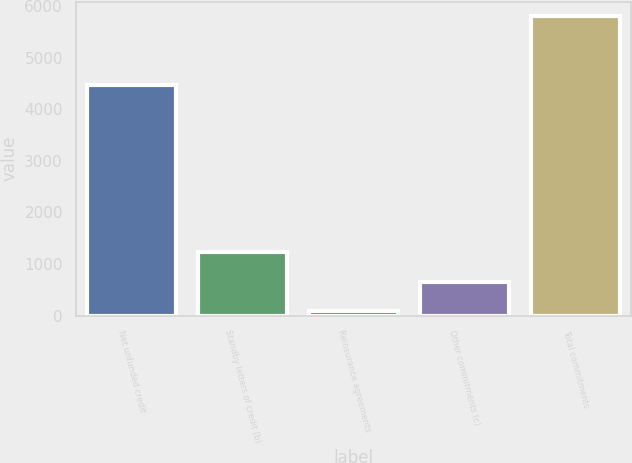Convert chart to OTSL. <chart><loc_0><loc_0><loc_500><loc_500><bar_chart><fcel>Net unfunded credit<fcel>Standby letters of credit (b)<fcel>Reinsurance agreements<fcel>Other commitments (c)<fcel>Total commitments<nl><fcel>4476<fcel>1229.2<fcel>86<fcel>657.6<fcel>5802<nl></chart> 